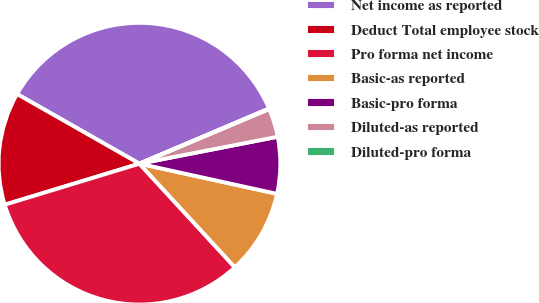Convert chart. <chart><loc_0><loc_0><loc_500><loc_500><pie_chart><fcel>Net income as reported<fcel>Deduct Total employee stock<fcel>Pro forma net income<fcel>Basic-as reported<fcel>Basic-pro forma<fcel>Diluted-as reported<fcel>Diluted-pro forma<nl><fcel>35.36%<fcel>12.94%<fcel>32.14%<fcel>9.72%<fcel>6.5%<fcel>3.28%<fcel>0.06%<nl></chart> 